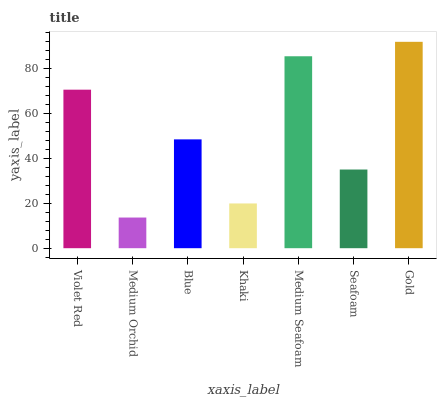Is Medium Orchid the minimum?
Answer yes or no. Yes. Is Gold the maximum?
Answer yes or no. Yes. Is Blue the minimum?
Answer yes or no. No. Is Blue the maximum?
Answer yes or no. No. Is Blue greater than Medium Orchid?
Answer yes or no. Yes. Is Medium Orchid less than Blue?
Answer yes or no. Yes. Is Medium Orchid greater than Blue?
Answer yes or no. No. Is Blue less than Medium Orchid?
Answer yes or no. No. Is Blue the high median?
Answer yes or no. Yes. Is Blue the low median?
Answer yes or no. Yes. Is Khaki the high median?
Answer yes or no. No. Is Medium Seafoam the low median?
Answer yes or no. No. 